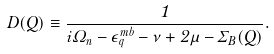<formula> <loc_0><loc_0><loc_500><loc_500>D ( Q ) \equiv \frac { 1 } { i \Omega _ { n } - \epsilon _ { q } ^ { m b } - \nu + 2 \mu - \Sigma _ { B } ( Q ) } .</formula> 